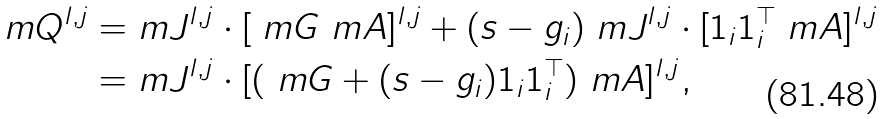Convert formula to latex. <formula><loc_0><loc_0><loc_500><loc_500>\ m Q ^ { l , j } = & \ m J ^ { l , j } \cdot [ \ m G \ m A ] ^ { l , j } + ( s - g _ { i } ) \ m J ^ { l , j } \cdot [ 1 _ { i } 1 _ { i } ^ { \top } \ m A ] ^ { l , j } \\ = & \ m J ^ { l , j } \cdot [ ( \ m G + ( s - g _ { i } ) 1 _ { i } 1 _ { i } ^ { \top } ) \ m A ] ^ { l , j } ,</formula> 